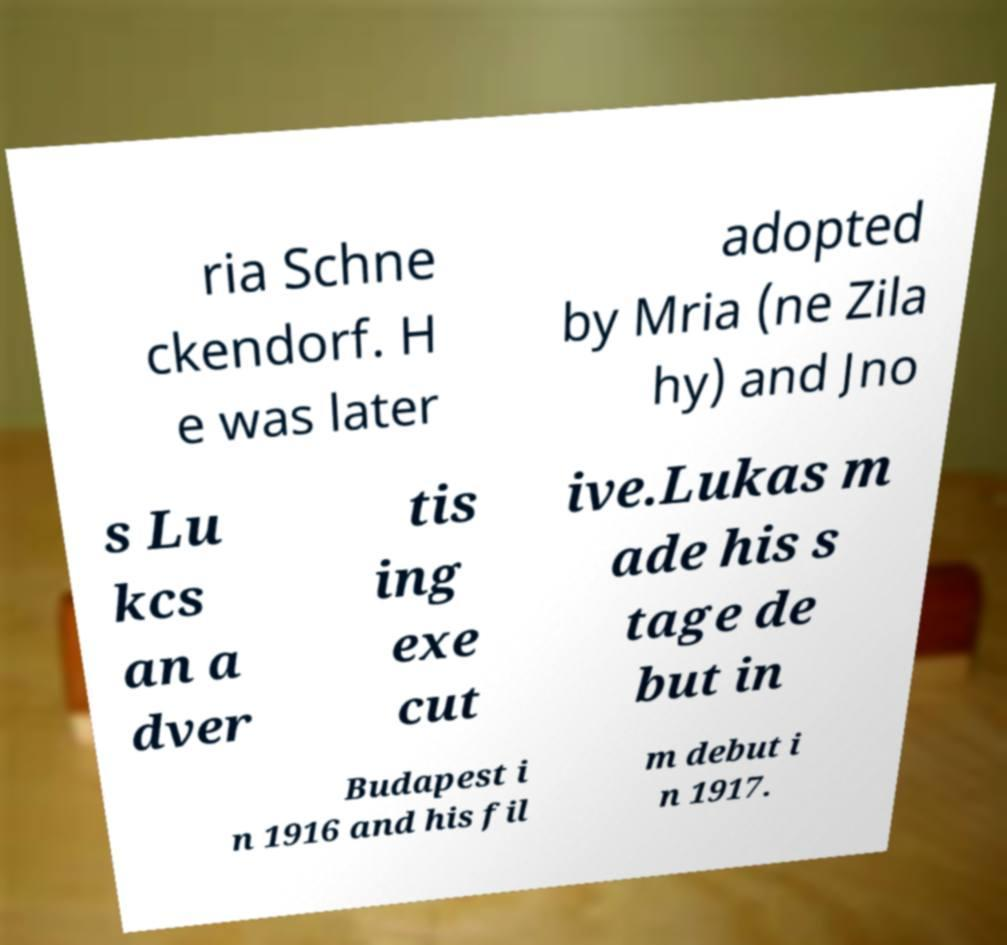Please read and relay the text visible in this image. What does it say? ria Schne ckendorf. H e was later adopted by Mria (ne Zila hy) and Jno s Lu kcs an a dver tis ing exe cut ive.Lukas m ade his s tage de but in Budapest i n 1916 and his fil m debut i n 1917. 